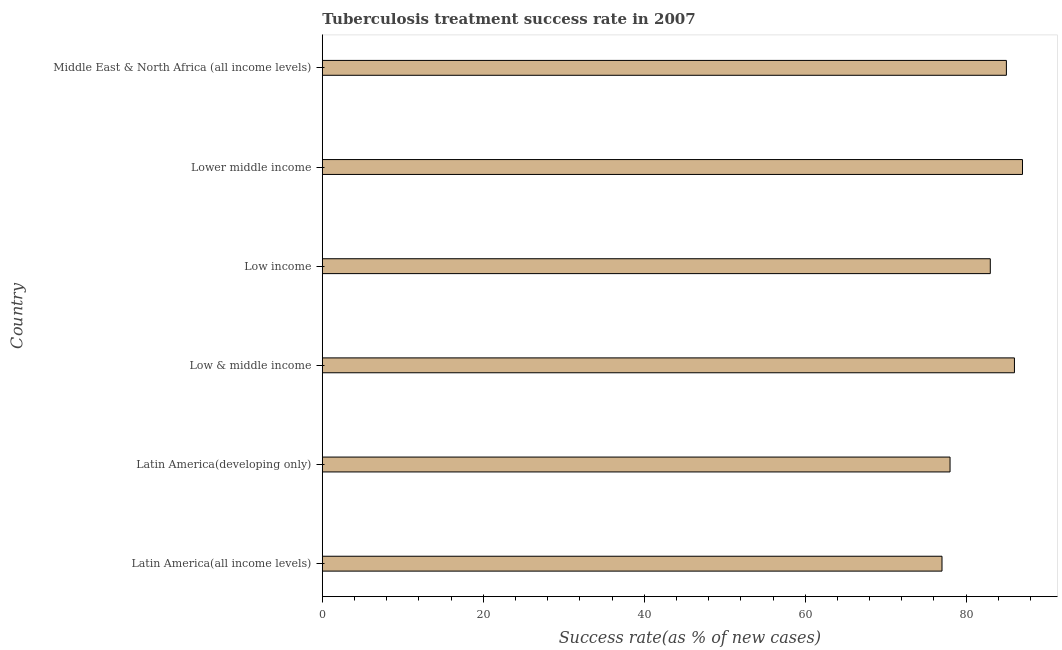Does the graph contain any zero values?
Provide a short and direct response. No. What is the title of the graph?
Give a very brief answer. Tuberculosis treatment success rate in 2007. What is the label or title of the X-axis?
Your response must be concise. Success rate(as % of new cases). Across all countries, what is the minimum tuberculosis treatment success rate?
Provide a succinct answer. 77. In which country was the tuberculosis treatment success rate maximum?
Offer a very short reply. Lower middle income. In which country was the tuberculosis treatment success rate minimum?
Make the answer very short. Latin America(all income levels). What is the sum of the tuberculosis treatment success rate?
Ensure brevity in your answer.  496. What is the difference between the tuberculosis treatment success rate in Latin America(developing only) and Low & middle income?
Offer a very short reply. -8. What is the ratio of the tuberculosis treatment success rate in Low & middle income to that in Lower middle income?
Your response must be concise. 0.99. Is the difference between the tuberculosis treatment success rate in Latin America(all income levels) and Low income greater than the difference between any two countries?
Your response must be concise. No. Is the sum of the tuberculosis treatment success rate in Latin America(developing only) and Middle East & North Africa (all income levels) greater than the maximum tuberculosis treatment success rate across all countries?
Your answer should be compact. Yes. In how many countries, is the tuberculosis treatment success rate greater than the average tuberculosis treatment success rate taken over all countries?
Provide a short and direct response. 4. How many bars are there?
Ensure brevity in your answer.  6. Are all the bars in the graph horizontal?
Provide a succinct answer. Yes. What is the Success rate(as % of new cases) of Latin America(all income levels)?
Provide a short and direct response. 77. What is the Success rate(as % of new cases) in Low income?
Provide a succinct answer. 83. What is the Success rate(as % of new cases) of Lower middle income?
Give a very brief answer. 87. What is the Success rate(as % of new cases) of Middle East & North Africa (all income levels)?
Your response must be concise. 85. What is the difference between the Success rate(as % of new cases) in Latin America(all income levels) and Low & middle income?
Give a very brief answer. -9. What is the difference between the Success rate(as % of new cases) in Latin America(all income levels) and Lower middle income?
Provide a succinct answer. -10. What is the difference between the Success rate(as % of new cases) in Latin America(all income levels) and Middle East & North Africa (all income levels)?
Give a very brief answer. -8. What is the difference between the Success rate(as % of new cases) in Latin America(developing only) and Low & middle income?
Your answer should be compact. -8. What is the difference between the Success rate(as % of new cases) in Latin America(developing only) and Low income?
Ensure brevity in your answer.  -5. What is the difference between the Success rate(as % of new cases) in Low & middle income and Lower middle income?
Provide a short and direct response. -1. What is the difference between the Success rate(as % of new cases) in Low & middle income and Middle East & North Africa (all income levels)?
Offer a very short reply. 1. What is the difference between the Success rate(as % of new cases) in Low income and Lower middle income?
Give a very brief answer. -4. What is the difference between the Success rate(as % of new cases) in Low income and Middle East & North Africa (all income levels)?
Your answer should be compact. -2. What is the ratio of the Success rate(as % of new cases) in Latin America(all income levels) to that in Low & middle income?
Your answer should be compact. 0.9. What is the ratio of the Success rate(as % of new cases) in Latin America(all income levels) to that in Low income?
Give a very brief answer. 0.93. What is the ratio of the Success rate(as % of new cases) in Latin America(all income levels) to that in Lower middle income?
Make the answer very short. 0.89. What is the ratio of the Success rate(as % of new cases) in Latin America(all income levels) to that in Middle East & North Africa (all income levels)?
Your answer should be compact. 0.91. What is the ratio of the Success rate(as % of new cases) in Latin America(developing only) to that in Low & middle income?
Ensure brevity in your answer.  0.91. What is the ratio of the Success rate(as % of new cases) in Latin America(developing only) to that in Lower middle income?
Provide a succinct answer. 0.9. What is the ratio of the Success rate(as % of new cases) in Latin America(developing only) to that in Middle East & North Africa (all income levels)?
Ensure brevity in your answer.  0.92. What is the ratio of the Success rate(as % of new cases) in Low & middle income to that in Low income?
Provide a succinct answer. 1.04. What is the ratio of the Success rate(as % of new cases) in Low income to that in Lower middle income?
Your response must be concise. 0.95. 